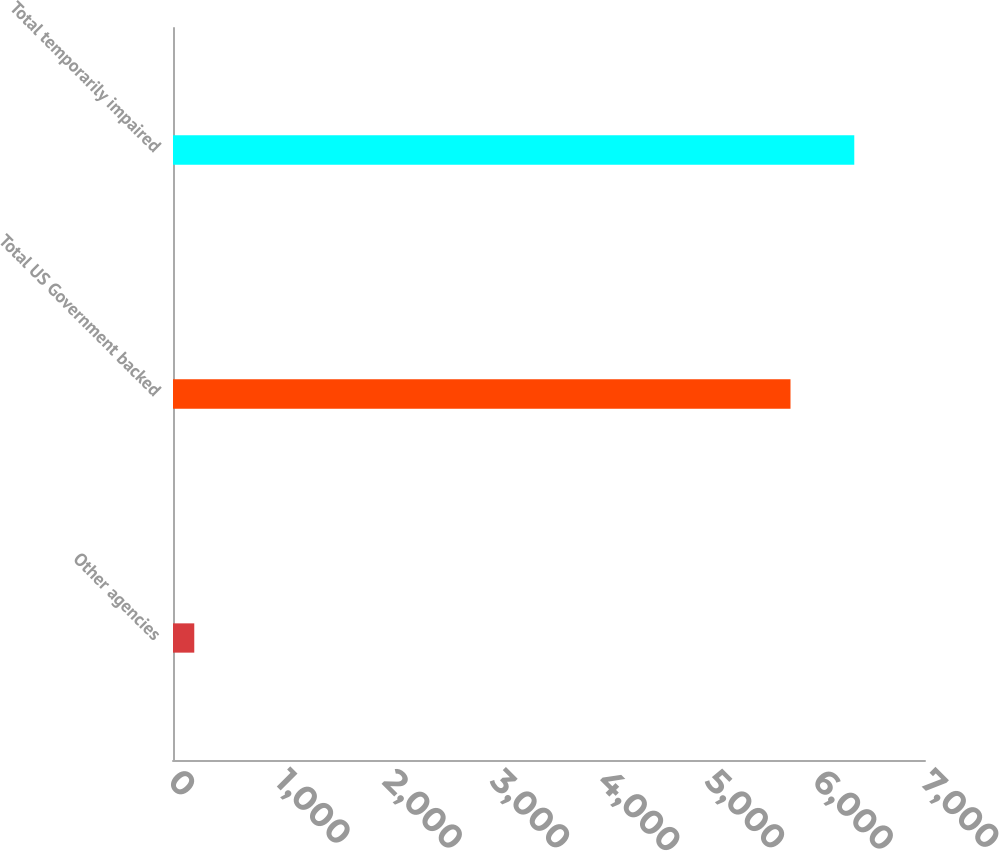Convert chart to OTSL. <chart><loc_0><loc_0><loc_500><loc_500><bar_chart><fcel>Other agencies<fcel>Total US Government backed<fcel>Total temporarily impaired<nl><fcel>198<fcel>5748<fcel>6341.7<nl></chart> 